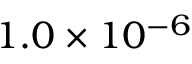Convert formula to latex. <formula><loc_0><loc_0><loc_500><loc_500>1 . 0 \times 1 0 ^ { - 6 }</formula> 